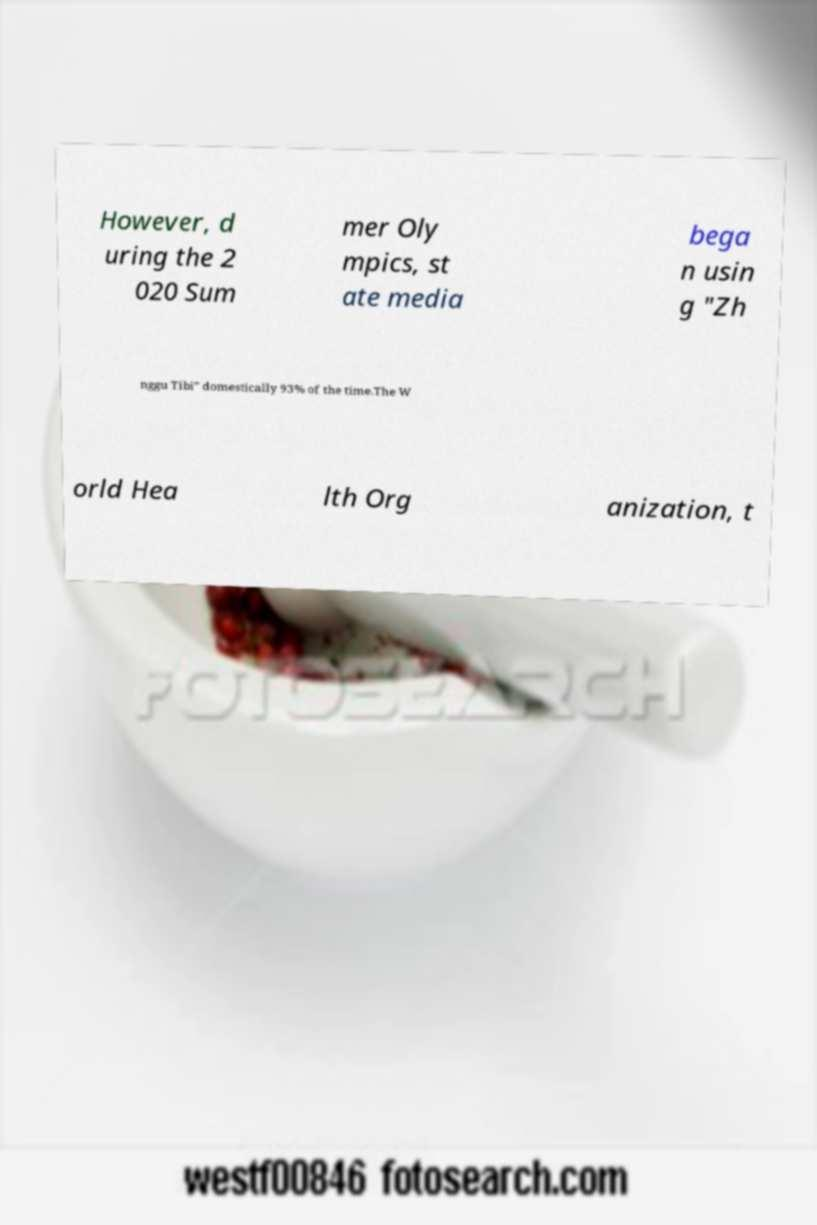For documentation purposes, I need the text within this image transcribed. Could you provide that? However, d uring the 2 020 Sum mer Oly mpics, st ate media bega n usin g "Zh nggu Tibi" domestically 93% of the time.The W orld Hea lth Org anization, t 